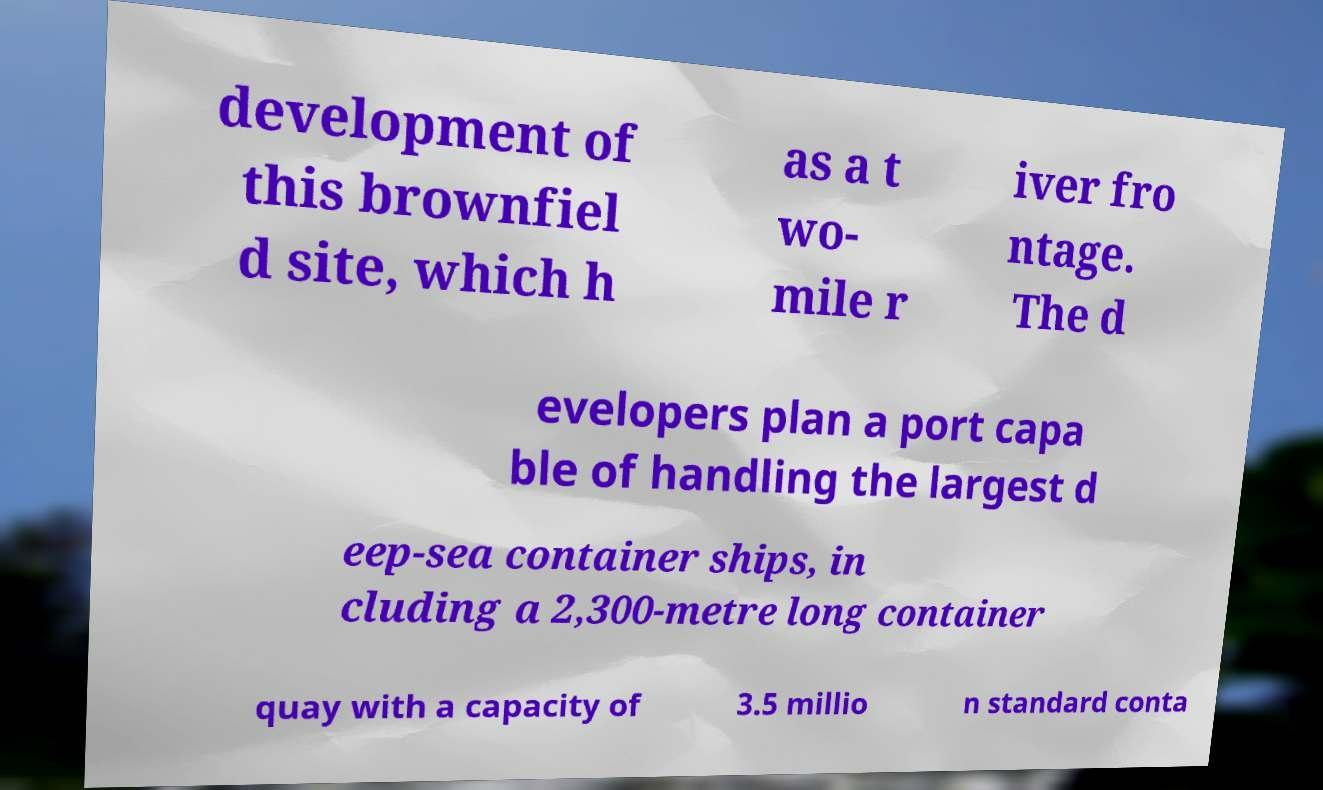What messages or text are displayed in this image? I need them in a readable, typed format. development of this brownfiel d site, which h as a t wo- mile r iver fro ntage. The d evelopers plan a port capa ble of handling the largest d eep-sea container ships, in cluding a 2,300-metre long container quay with a capacity of 3.5 millio n standard conta 